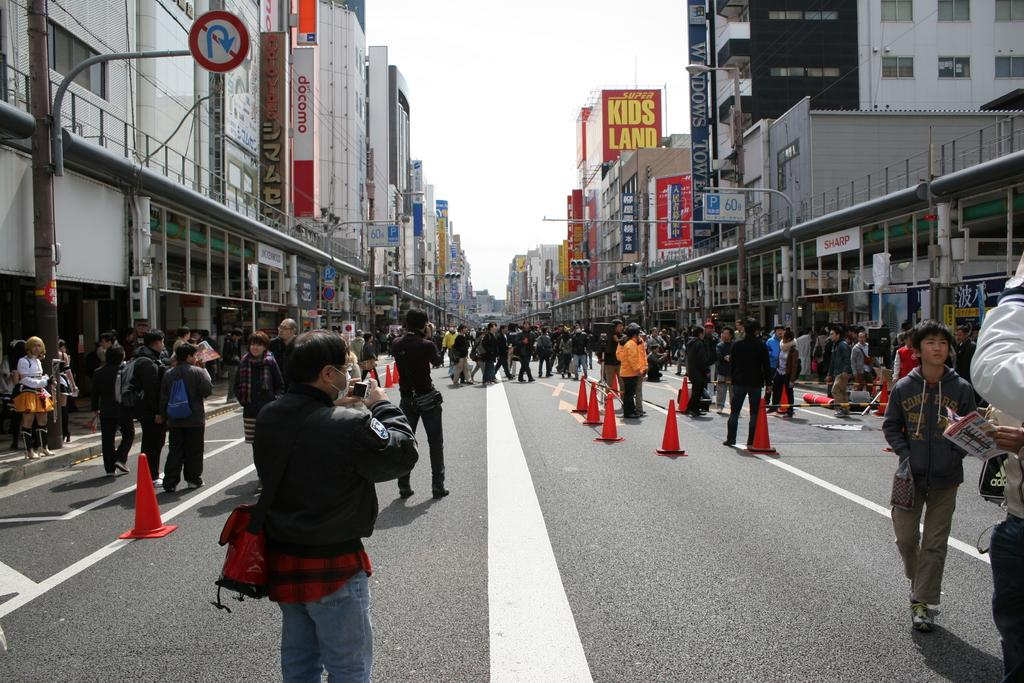What are the people in the image doing? The people in the image are walking on the streets. What can be seen on either side of the street? There are buildings and lamp posts on either side of the street. Are there any signs to help with navigation in the image? Yes, direction signs are present on either side of the street. What type of steel is used to construct the wave in the image? There is no wave or steel present in the image; it features people walking on the streets with buildings and lamp posts on either side. 